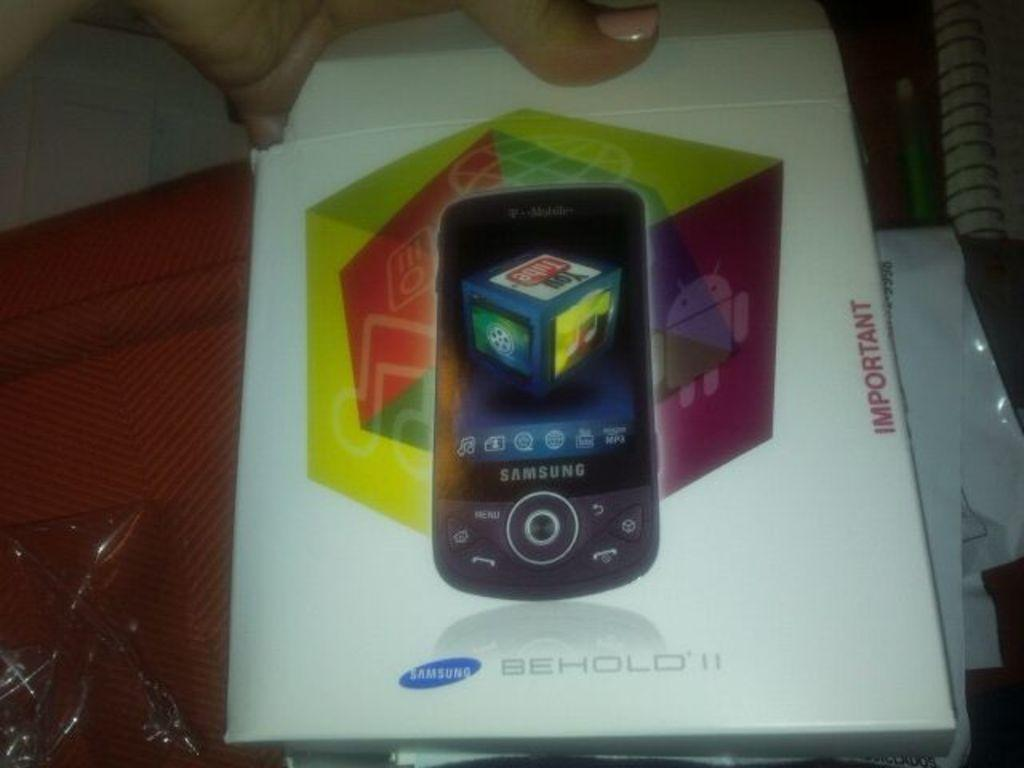<image>
Write a terse but informative summary of the picture. A case of a new Samsung phone inside 